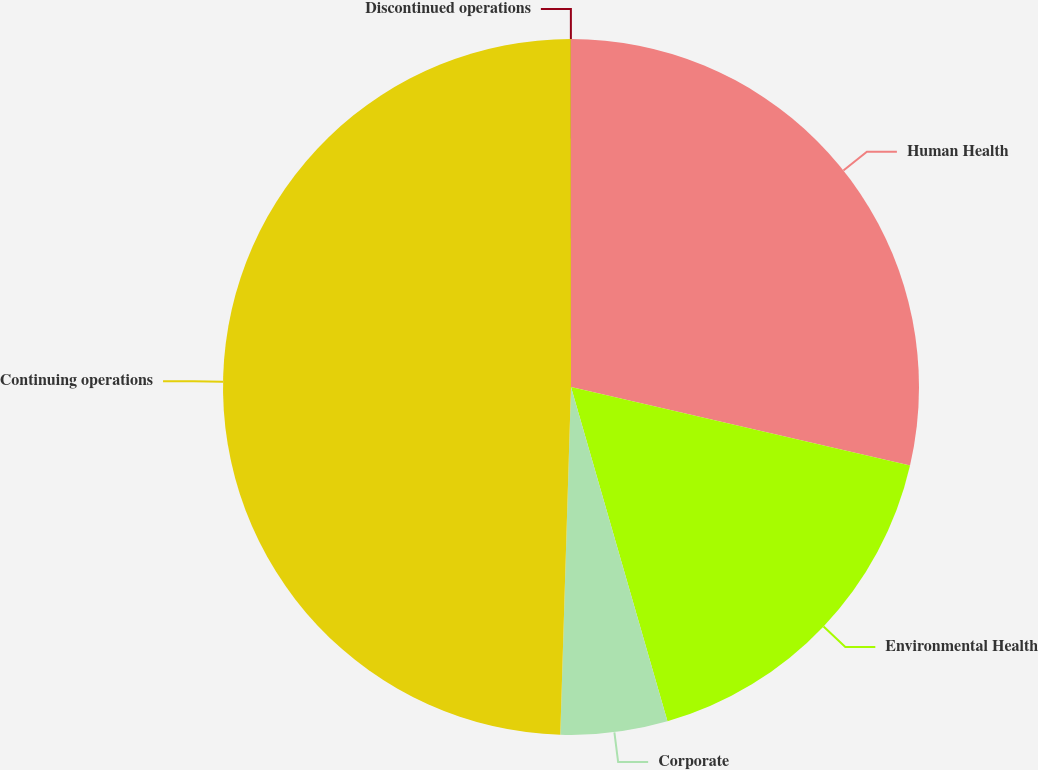<chart> <loc_0><loc_0><loc_500><loc_500><pie_chart><fcel>Human Health<fcel>Environmental Health<fcel>Corporate<fcel>Continuing operations<fcel>Discontinued operations<nl><fcel>28.62%<fcel>16.91%<fcel>4.96%<fcel>49.5%<fcel>0.01%<nl></chart> 